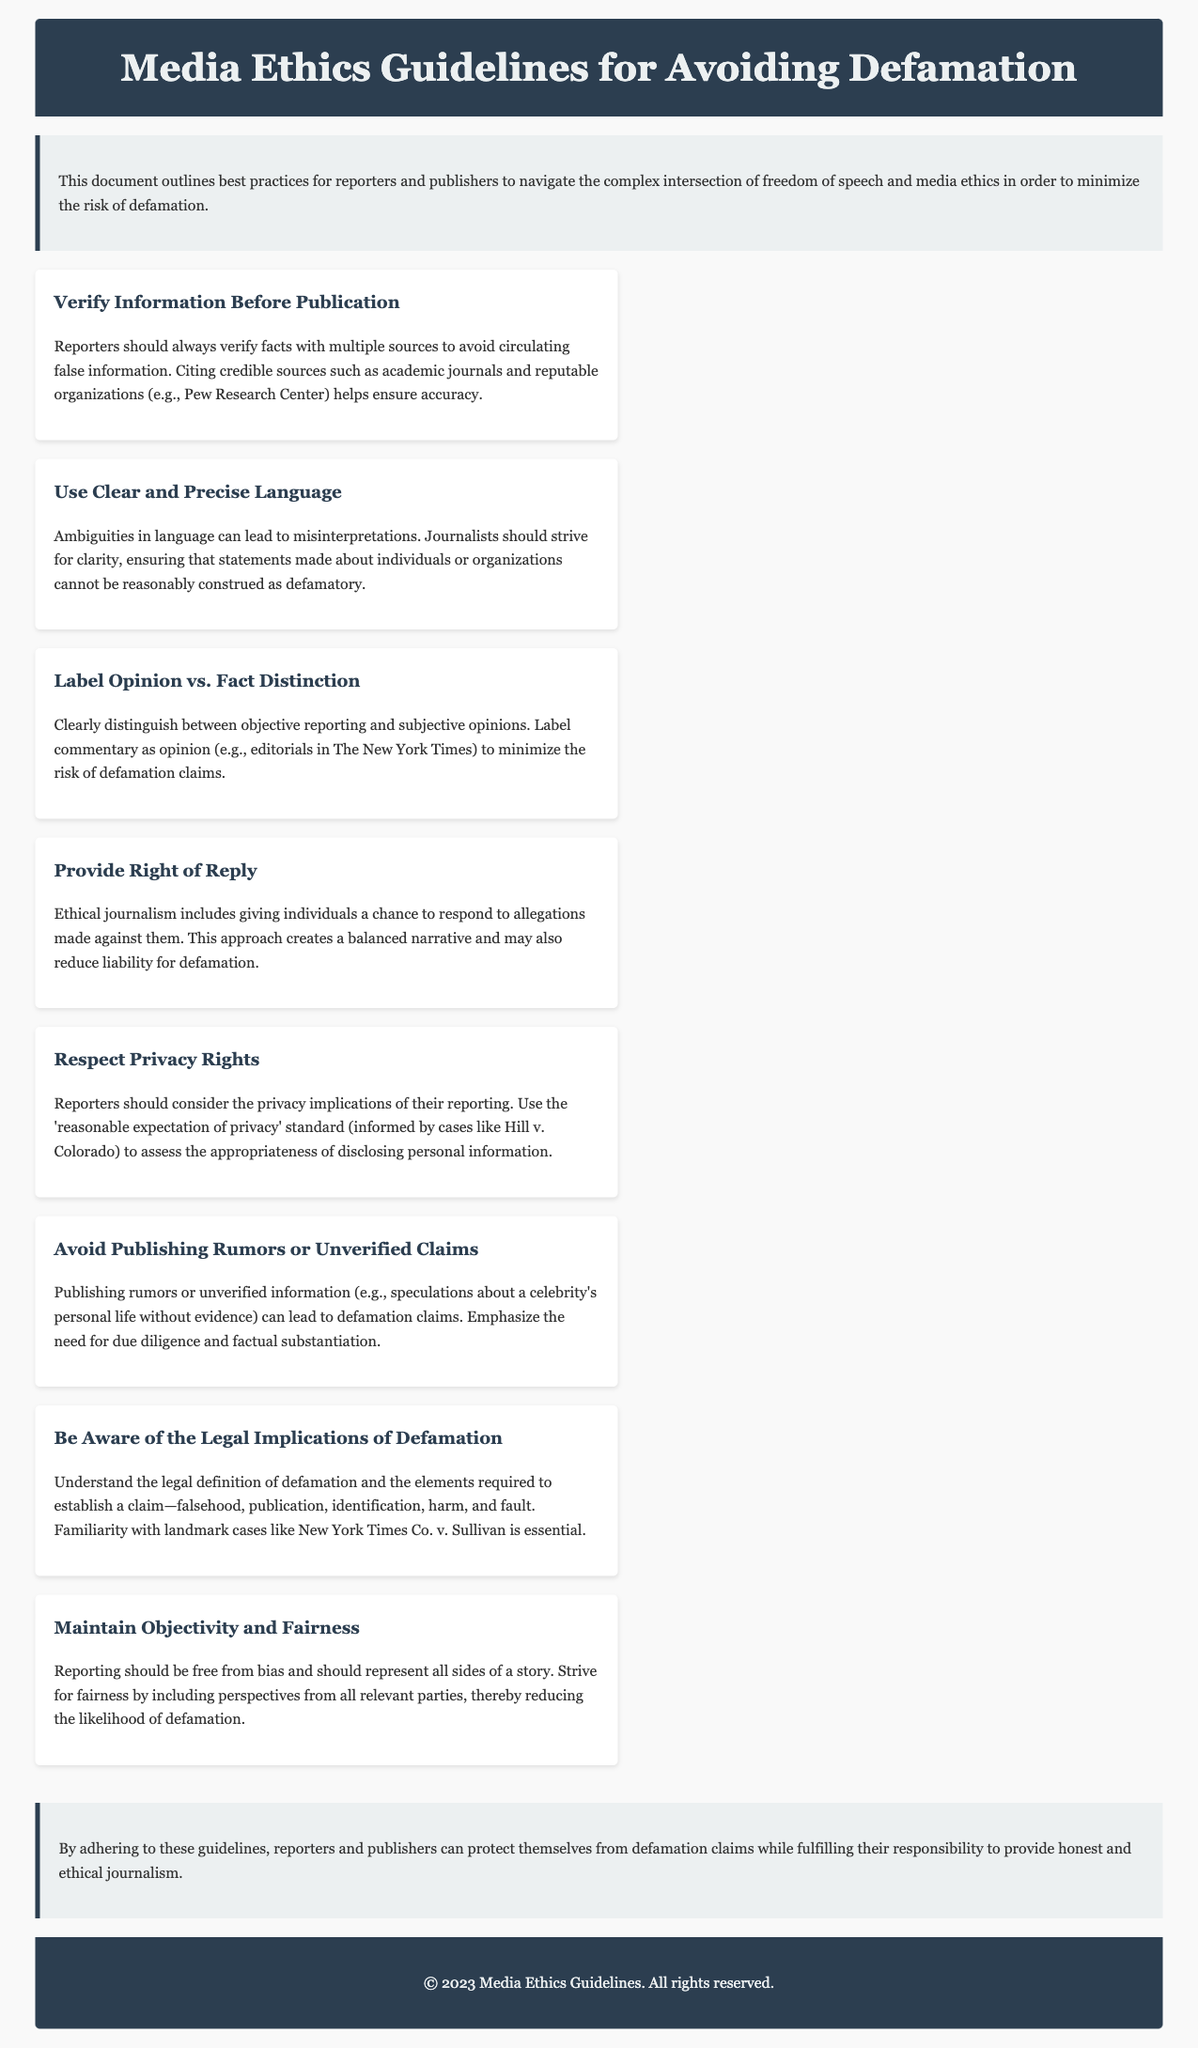What is the title of the document? The title is specified in the header section of the document.
Answer: Media Ethics Guidelines for Avoiding Defamation How many main guideline sections are there? The document lists eight specific guidelines aimed at avoiding defamation.
Answer: Eight Which legal case is mentioned regarding defamation? The document references a landmark case that helps understand defamation law.
Answer: New York Times Co. v. Sullivan What should reporters do before publication? The guidelines emphasize the importance of verifying information before it is made public.
Answer: Verify Information Before Publication What is one way to minimize defamation claims according to the document? The document suggests giving individuals a chance to respond to allegations made against them.
Answer: Provide Right of Reply What is the guideline regarding the distinction between opinion and fact? The guideline emphasizes the importance of labeling opinions clearly to avoid misinterpretations.
Answer: Label Opinion vs. Fact Distinction What standard should be used to assess privacy implications? The document mentions a legal case that informs the privacy rights standard reporters should use.
Answer: reasonable expectation of privacy What does the introduction state the document aims to navigate? The introduction highlights the complex intersection that will be addressed.
Answer: freedom of speech and media ethics 